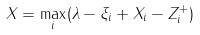Convert formula to latex. <formula><loc_0><loc_0><loc_500><loc_500>X = \max _ { i } ( \lambda - \xi _ { i } + X _ { i } - Z _ { i } ^ { + } )</formula> 